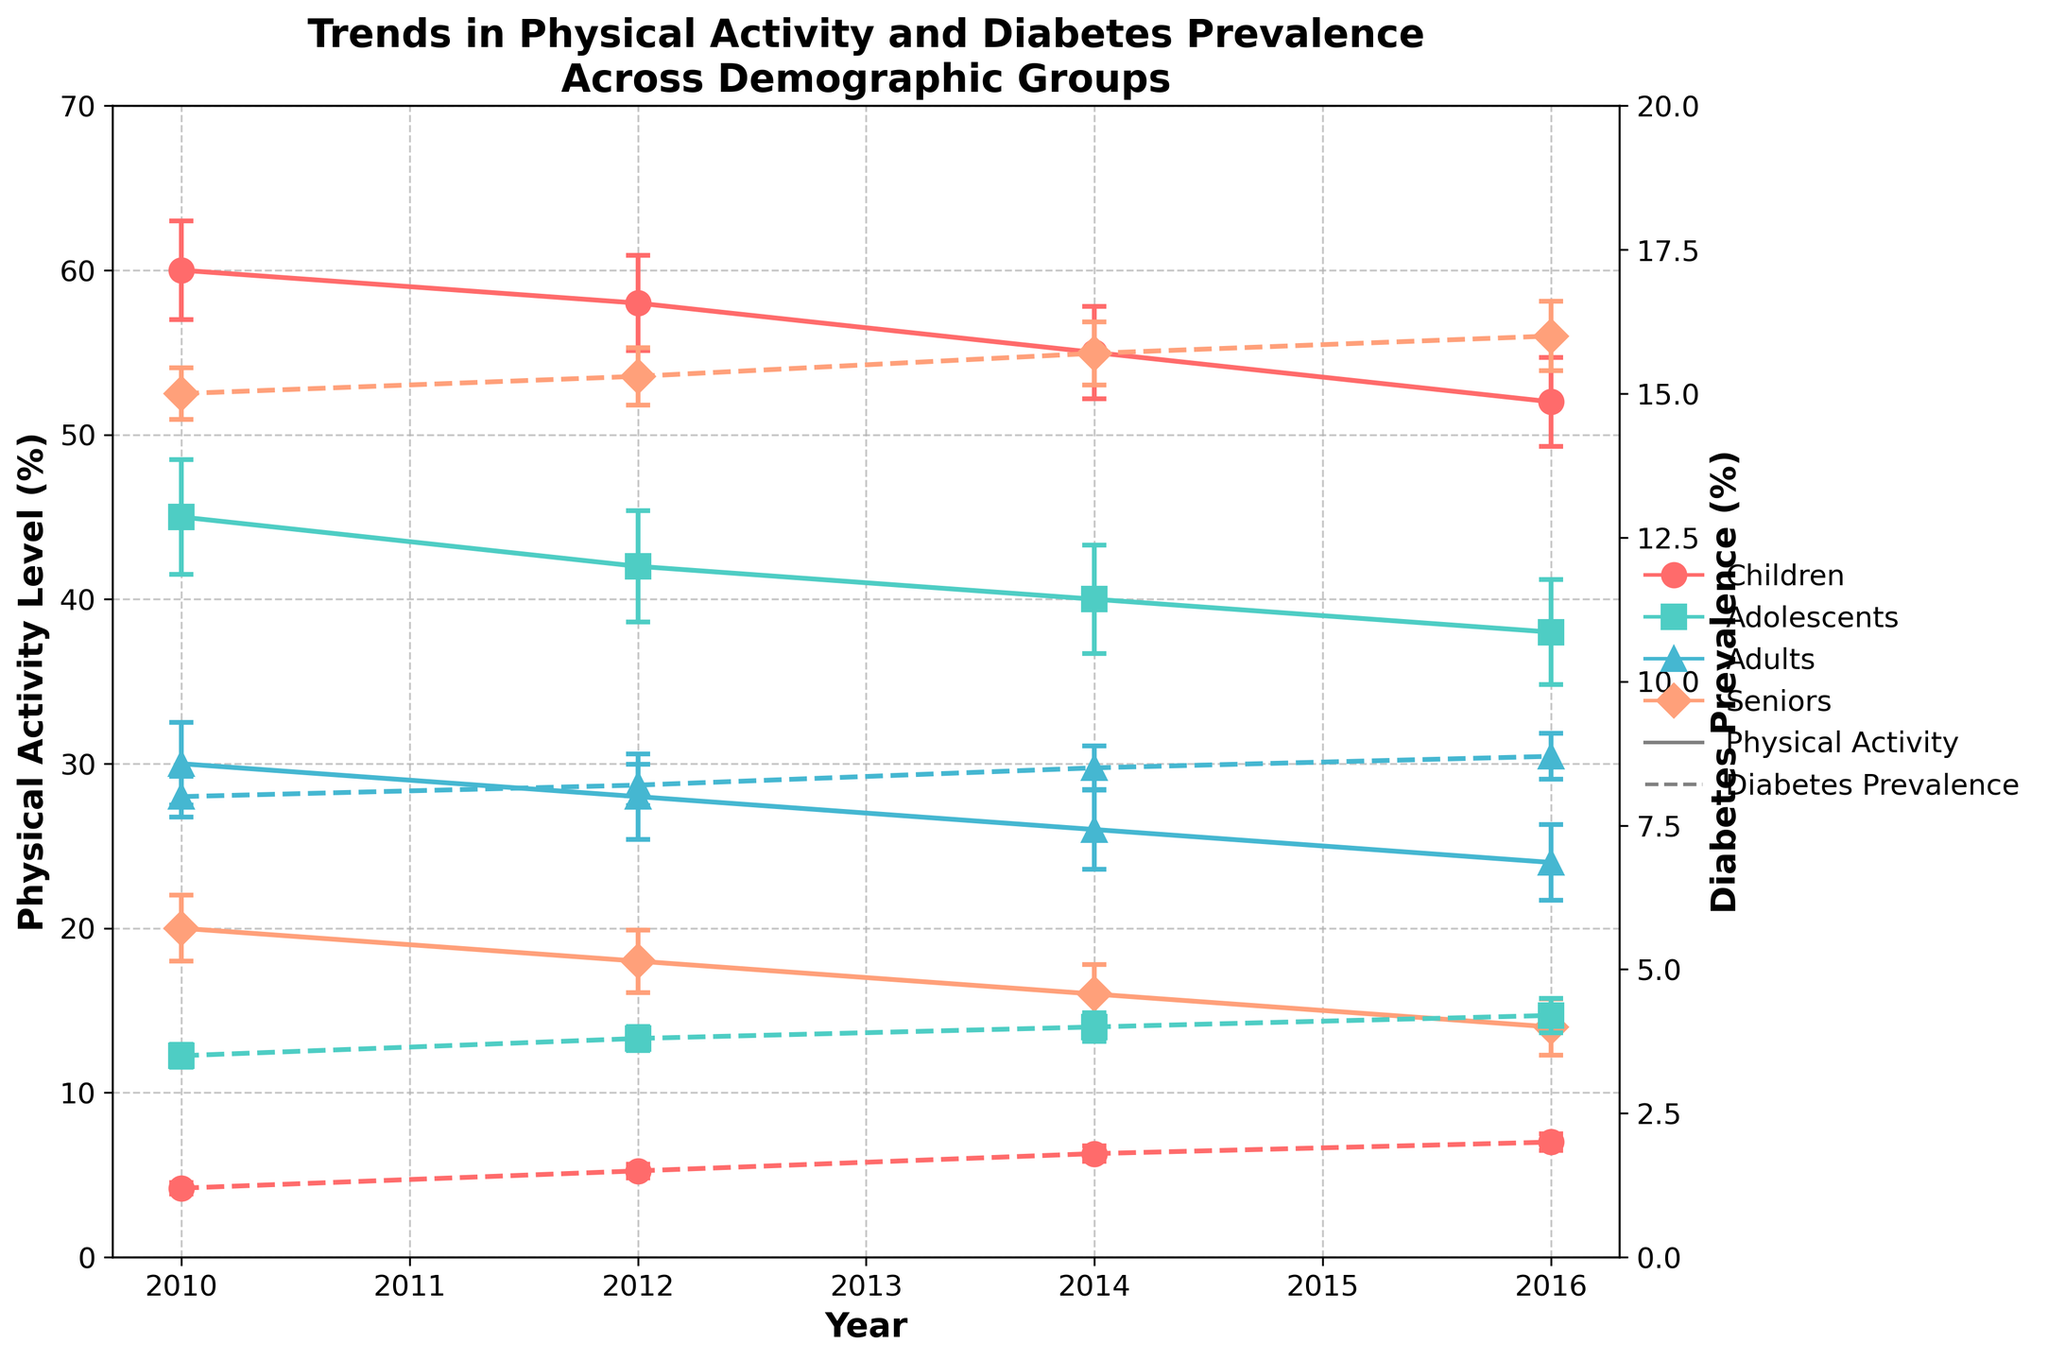What does the x-axis represent? The x-axis represents the years over which physical activity levels and diabetes prevalence were tracked across different demographic groups. It goes from 2010 to 2016.
Answer: Years (2010 to 2016) What demographic group has the highest physical activity level in 2010? By looking at the physical activity levels in 2010, we see that the 'Children' group has the highest level at 60%.
Answer: Children Between which years did the 'Seniors' demographic see the greatest drop in physical activity level? Observing the slope of the line representing the 'Seniors' group, the greatest drop in physical activity level is between 2012 and 2014, falling from 18% to 16%.
Answer: 2012 to 2014 How does diabetes prevalence in 'Adolescents' compare to 'Adults' in 2016? In 2016, the diabetes prevalence for 'Adolescents' is around 4.2%, whereas for 'Adults' it is around 8.7%. Adults have a higher diabetes prevalence compared to Adolescents.
Answer: Adults have higher prevalence Which group has the smallest standard error for physical activity levels in 2016? The standard error for the physical activity level in 2016 can be observed via the error bars. The 'Adults' group has the smallest standard error, given their smaller error bars.
Answer: Adults What is the trend in diabetes prevalence for 'Children' from 2010 to 2016? The diabetes prevalence for 'Children' increases over the years from 1.2% in 2010 to 2.0% in 2016, indicating an upward trend.
Answer: Upward trend Calculate the average physical activity level for 'Adolescents' over the years presented. Summing the physical activity levels for 'Adolescents' over the years (45, 42, 40, 38) gives 165, and there are four data points. So, the average is 165/4 = 41.25%.
Answer: 41.25% In which year is the diabetes prevalence highest for 'Seniors'? Looking at the diabetes prevalence for 'Seniors' from the plot, the highest prevalence is in 2016 at 16.0%.
Answer: 2016 